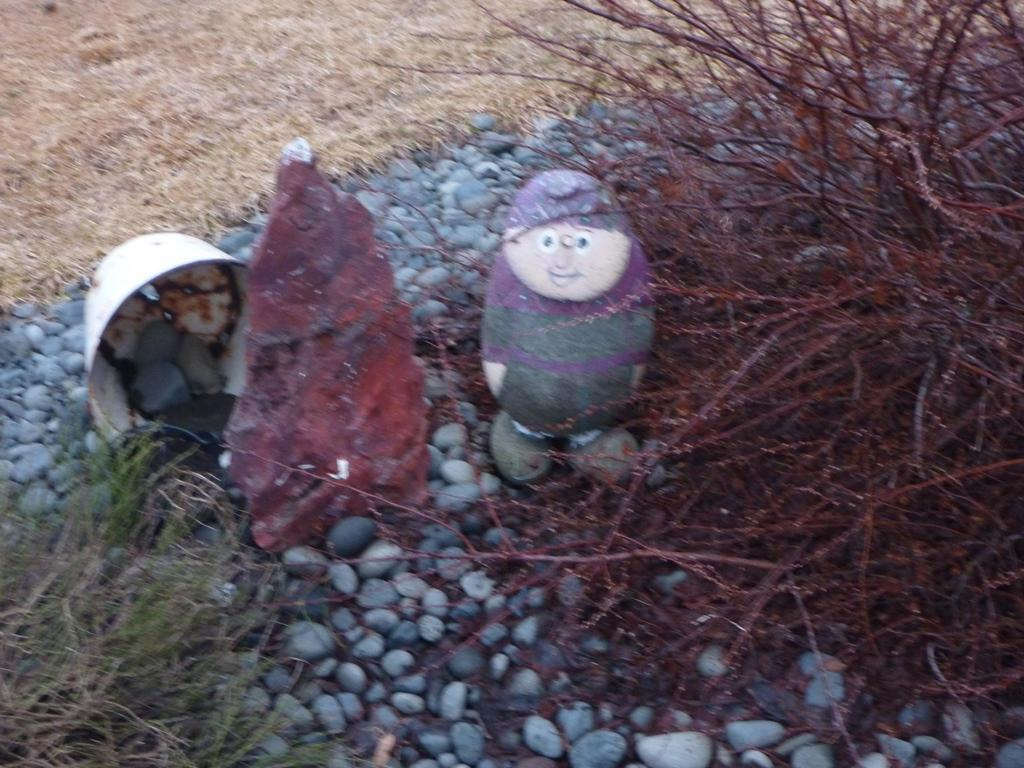What is the main subject of the image? There is a sculpture in the image. What materials were used to create the sculpture? The sculpture is made with pebbles and grass. Where is the sculpture located? The sculpture is on the ground. What type of potato is being used to create the sculpture in the image? There is no potato present in the image; the sculpture is made with pebbles and grass. How many beans are visible in the image? There are no beans present in the image. 